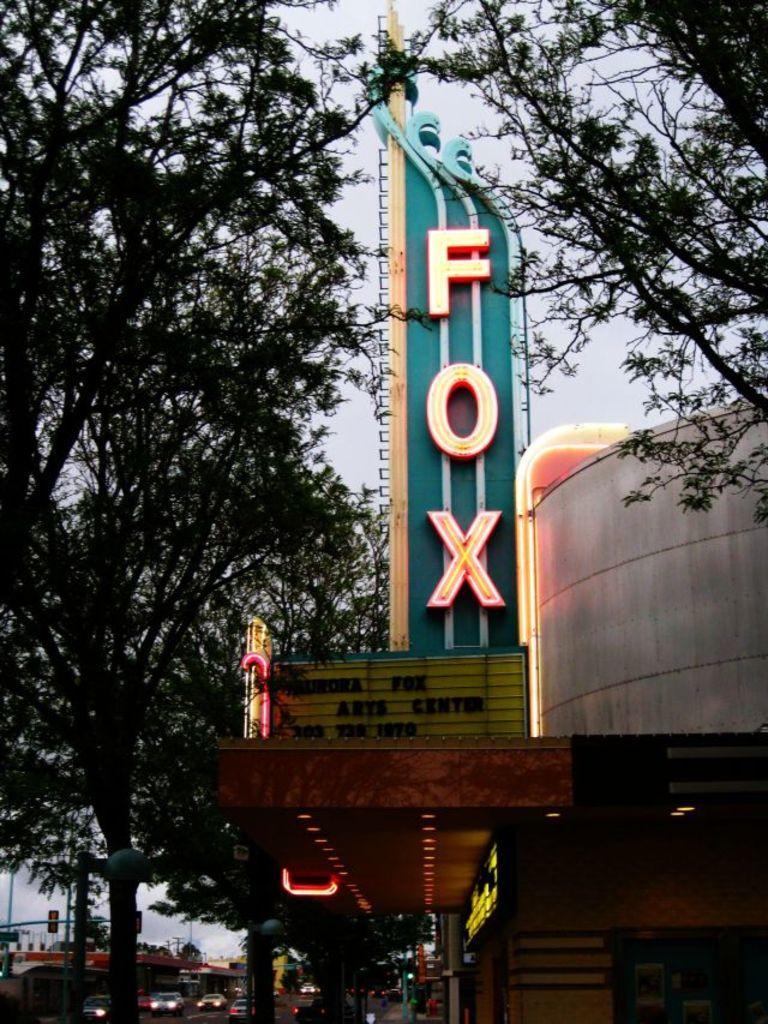Can you describe this image briefly? In this image, we can see hoarding, house, lights, trees, wall. At the bottom, we can see few vehicles, poles. Background there is a sky. 